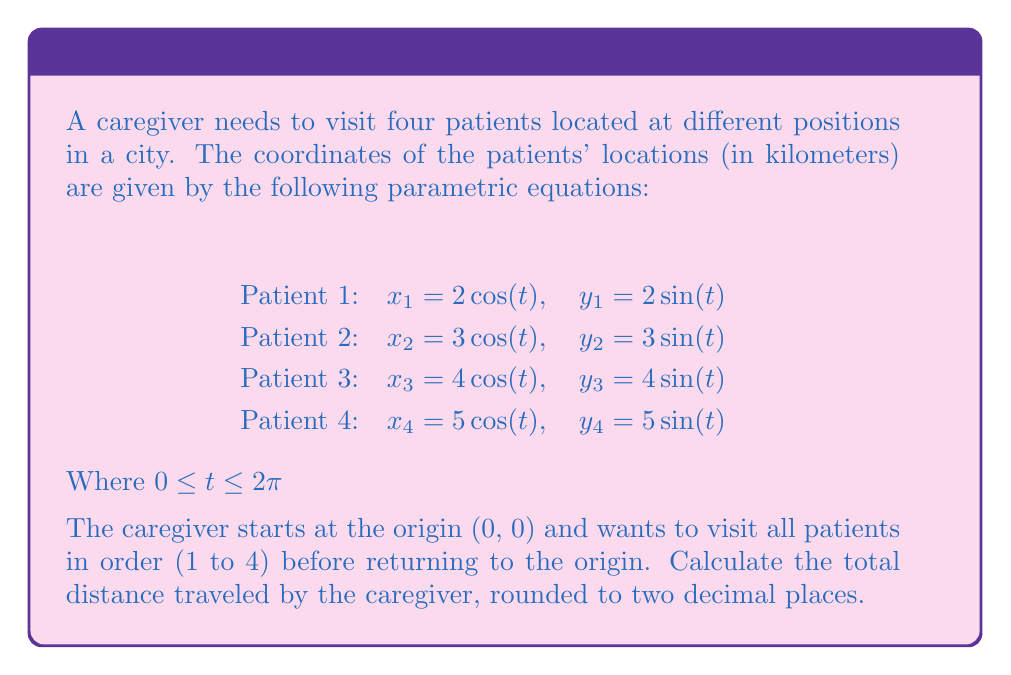Solve this math problem. To solve this problem, we need to follow these steps:

1) First, we need to find the position of each patient. Since we're not given a specific value for $t$, we can choose $t = 0$ for simplicity. At $t = 0$:

   Patient 1: $(2, 0)$
   Patient 2: $(3, 0)$
   Patient 3: $(4, 0)$
   Patient 4: $(5, 0)$

2) Now, we need to calculate the distance between each point in the path:
   
   Origin to Patient 1: $\sqrt{(2-0)^2 + (0-0)^2} = 2$
   Patient 1 to Patient 2: $\sqrt{(3-2)^2 + (0-0)^2} = 1$
   Patient 2 to Patient 3: $\sqrt{(4-3)^2 + (0-0)^2} = 1$
   Patient 3 to Patient 4: $\sqrt{(5-4)^2 + (0-0)^2} = 1$
   Patient 4 back to Origin: $\sqrt{(0-5)^2 + (0-0)^2} = 5$

3) The total distance is the sum of all these segments:

   Total distance = $2 + 1 + 1 + 1 + 5 = 10$ km

Therefore, the total distance traveled by the caregiver is 10 km.
Answer: 10.00 km 